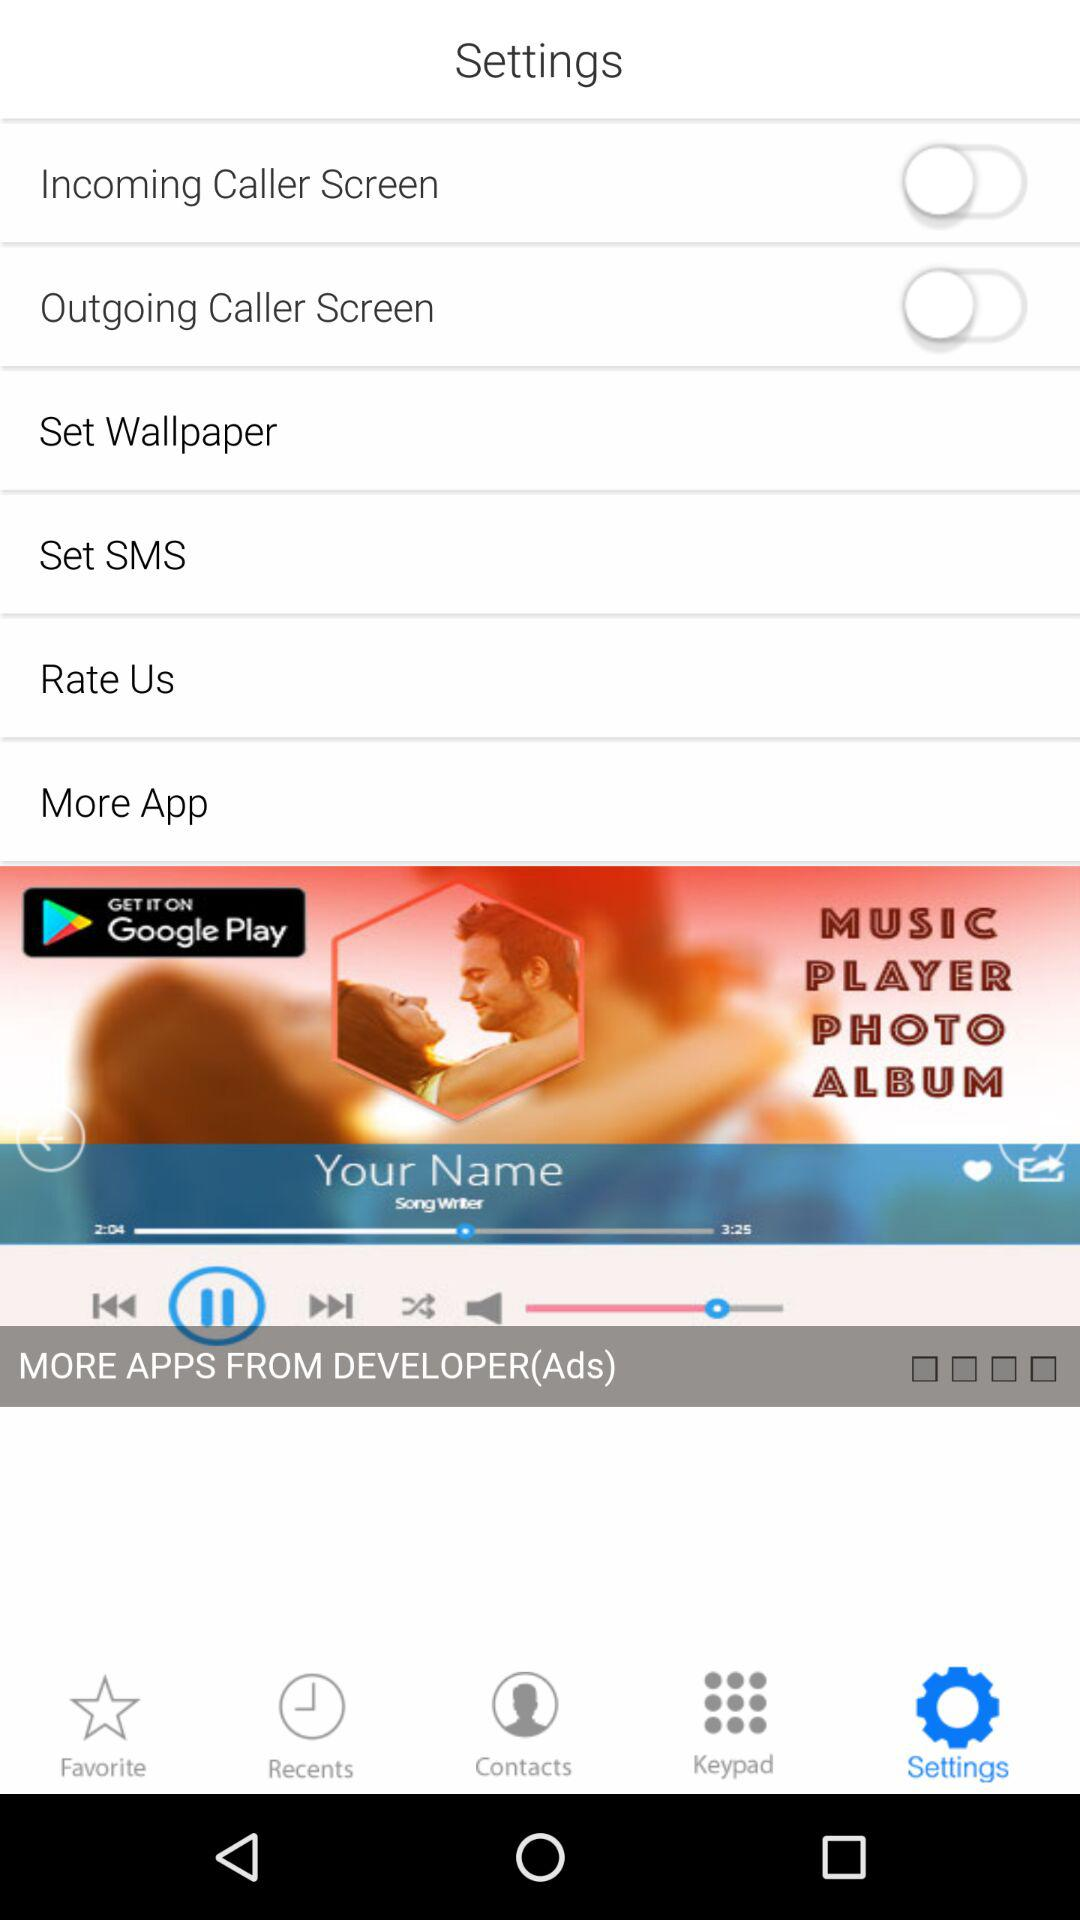What is the status of "Outgoing Caller Screen"? The status is "off". 